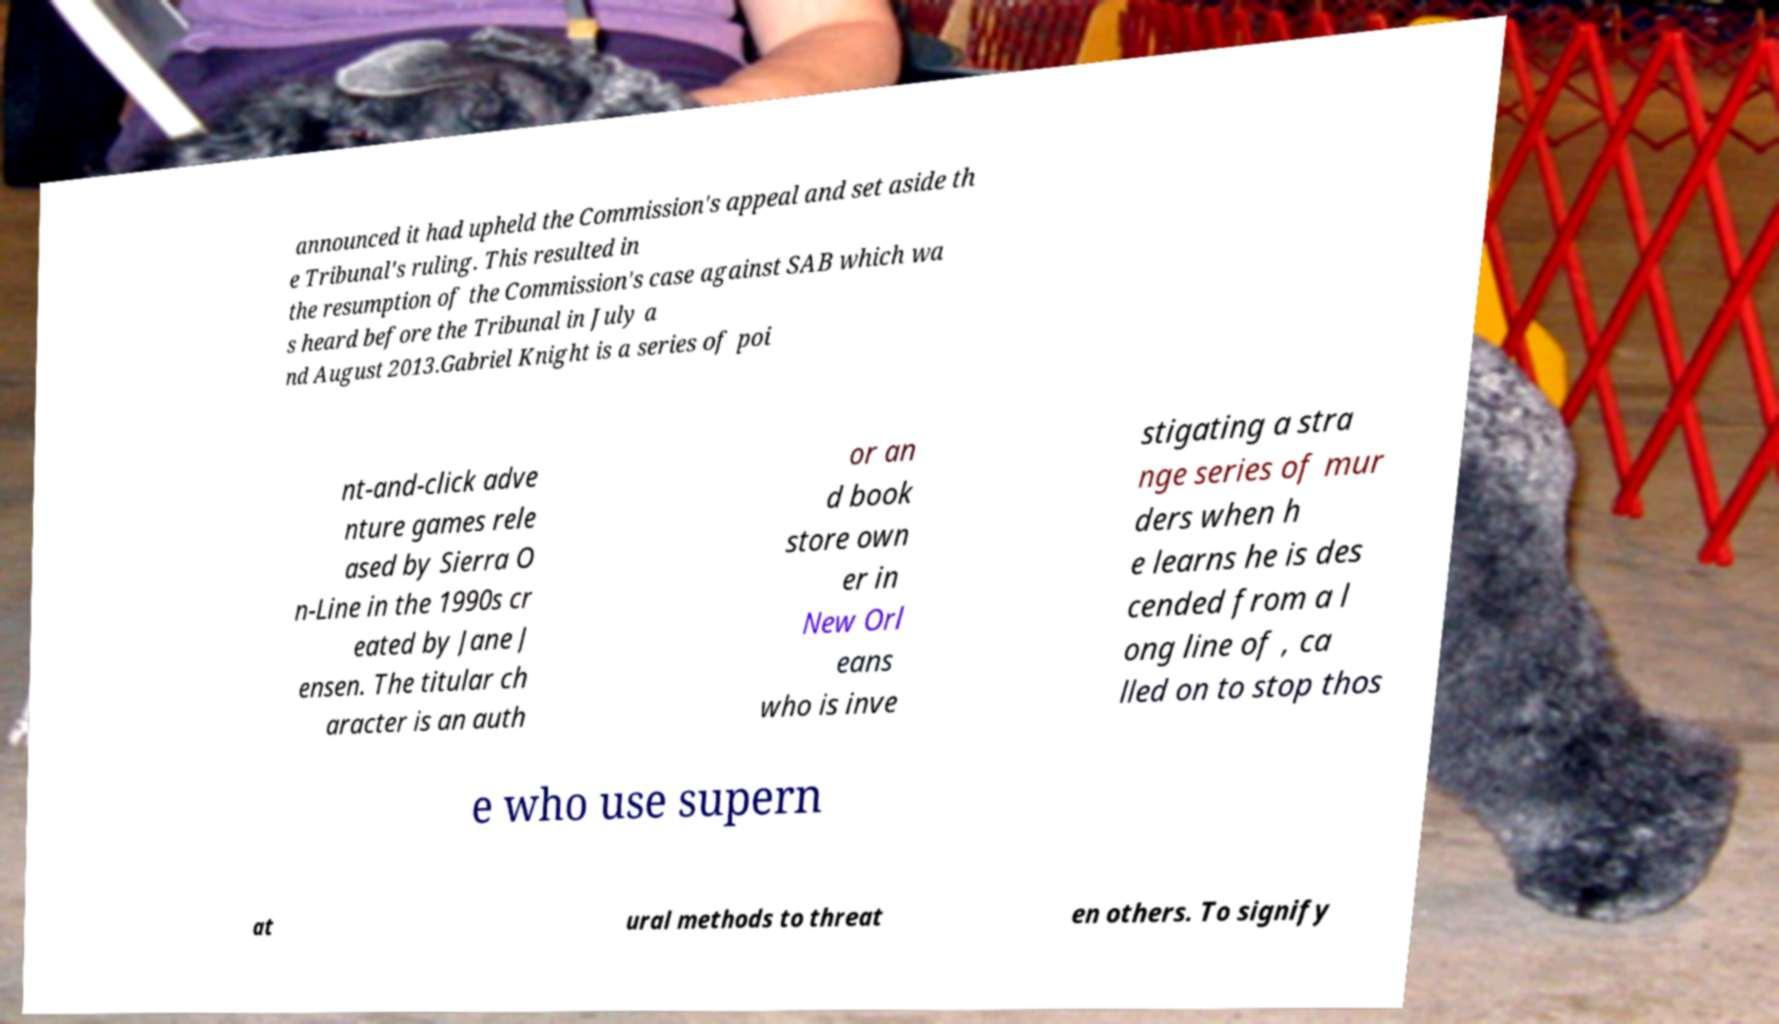Can you read and provide the text displayed in the image?This photo seems to have some interesting text. Can you extract and type it out for me? announced it had upheld the Commission's appeal and set aside th e Tribunal's ruling. This resulted in the resumption of the Commission's case against SAB which wa s heard before the Tribunal in July a nd August 2013.Gabriel Knight is a series of poi nt-and-click adve nture games rele ased by Sierra O n-Line in the 1990s cr eated by Jane J ensen. The titular ch aracter is an auth or an d book store own er in New Orl eans who is inve stigating a stra nge series of mur ders when h e learns he is des cended from a l ong line of , ca lled on to stop thos e who use supern at ural methods to threat en others. To signify 